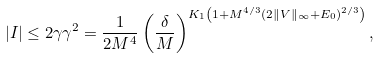<formula> <loc_0><loc_0><loc_500><loc_500>| I | \leq 2 \gamma \gamma ^ { 2 } = \frac { 1 } { 2 M ^ { 4 } } \left ( \frac { \delta } { M } \right ) ^ { K _ { 1 } \left ( 1 + M ^ { 4 / 3 } ( 2 \| V \| _ { \infty } + E _ { 0 } ) ^ { 2 / 3 } \right ) } ,</formula> 